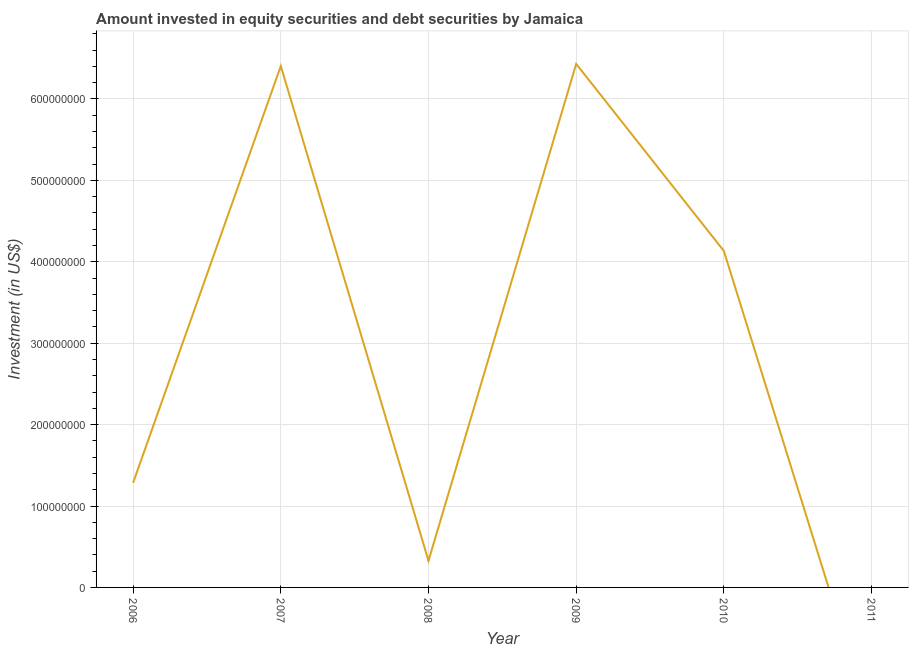What is the portfolio investment in 2008?
Your answer should be very brief. 3.28e+07. Across all years, what is the maximum portfolio investment?
Your answer should be compact. 6.43e+08. Across all years, what is the minimum portfolio investment?
Offer a very short reply. 0. In which year was the portfolio investment maximum?
Keep it short and to the point. 2009. What is the sum of the portfolio investment?
Offer a terse response. 1.86e+09. What is the difference between the portfolio investment in 2006 and 2010?
Offer a very short reply. -2.85e+08. What is the average portfolio investment per year?
Your answer should be very brief. 3.10e+08. What is the median portfolio investment?
Provide a succinct answer. 2.71e+08. In how many years, is the portfolio investment greater than 80000000 US$?
Provide a succinct answer. 4. What is the ratio of the portfolio investment in 2008 to that in 2009?
Make the answer very short. 0.05. What is the difference between the highest and the second highest portfolio investment?
Your response must be concise. 2.60e+06. Is the sum of the portfolio investment in 2006 and 2007 greater than the maximum portfolio investment across all years?
Ensure brevity in your answer.  Yes. What is the difference between the highest and the lowest portfolio investment?
Ensure brevity in your answer.  6.43e+08. In how many years, is the portfolio investment greater than the average portfolio investment taken over all years?
Your response must be concise. 3. Does the portfolio investment monotonically increase over the years?
Your response must be concise. No. How many years are there in the graph?
Offer a terse response. 6. What is the difference between two consecutive major ticks on the Y-axis?
Your answer should be compact. 1.00e+08. Does the graph contain grids?
Offer a terse response. Yes. What is the title of the graph?
Provide a short and direct response. Amount invested in equity securities and debt securities by Jamaica. What is the label or title of the X-axis?
Ensure brevity in your answer.  Year. What is the label or title of the Y-axis?
Provide a short and direct response. Investment (in US$). What is the Investment (in US$) of 2006?
Your response must be concise. 1.29e+08. What is the Investment (in US$) of 2007?
Offer a very short reply. 6.40e+08. What is the Investment (in US$) of 2008?
Your response must be concise. 3.28e+07. What is the Investment (in US$) in 2009?
Provide a succinct answer. 6.43e+08. What is the Investment (in US$) in 2010?
Offer a terse response. 4.13e+08. What is the Investment (in US$) in 2011?
Make the answer very short. 0. What is the difference between the Investment (in US$) in 2006 and 2007?
Ensure brevity in your answer.  -5.12e+08. What is the difference between the Investment (in US$) in 2006 and 2008?
Keep it short and to the point. 9.58e+07. What is the difference between the Investment (in US$) in 2006 and 2009?
Your response must be concise. -5.15e+08. What is the difference between the Investment (in US$) in 2006 and 2010?
Your answer should be compact. -2.85e+08. What is the difference between the Investment (in US$) in 2007 and 2008?
Provide a succinct answer. 6.08e+08. What is the difference between the Investment (in US$) in 2007 and 2009?
Provide a short and direct response. -2.60e+06. What is the difference between the Investment (in US$) in 2007 and 2010?
Your response must be concise. 2.27e+08. What is the difference between the Investment (in US$) in 2008 and 2009?
Your answer should be very brief. -6.10e+08. What is the difference between the Investment (in US$) in 2008 and 2010?
Your response must be concise. -3.80e+08. What is the difference between the Investment (in US$) in 2009 and 2010?
Offer a very short reply. 2.30e+08. What is the ratio of the Investment (in US$) in 2006 to that in 2007?
Keep it short and to the point. 0.2. What is the ratio of the Investment (in US$) in 2006 to that in 2008?
Provide a succinct answer. 3.92. What is the ratio of the Investment (in US$) in 2006 to that in 2010?
Ensure brevity in your answer.  0.31. What is the ratio of the Investment (in US$) in 2007 to that in 2008?
Your answer should be very brief. 19.55. What is the ratio of the Investment (in US$) in 2007 to that in 2009?
Provide a succinct answer. 1. What is the ratio of the Investment (in US$) in 2007 to that in 2010?
Offer a very short reply. 1.55. What is the ratio of the Investment (in US$) in 2008 to that in 2009?
Give a very brief answer. 0.05. What is the ratio of the Investment (in US$) in 2008 to that in 2010?
Your answer should be very brief. 0.08. What is the ratio of the Investment (in US$) in 2009 to that in 2010?
Your answer should be compact. 1.56. 